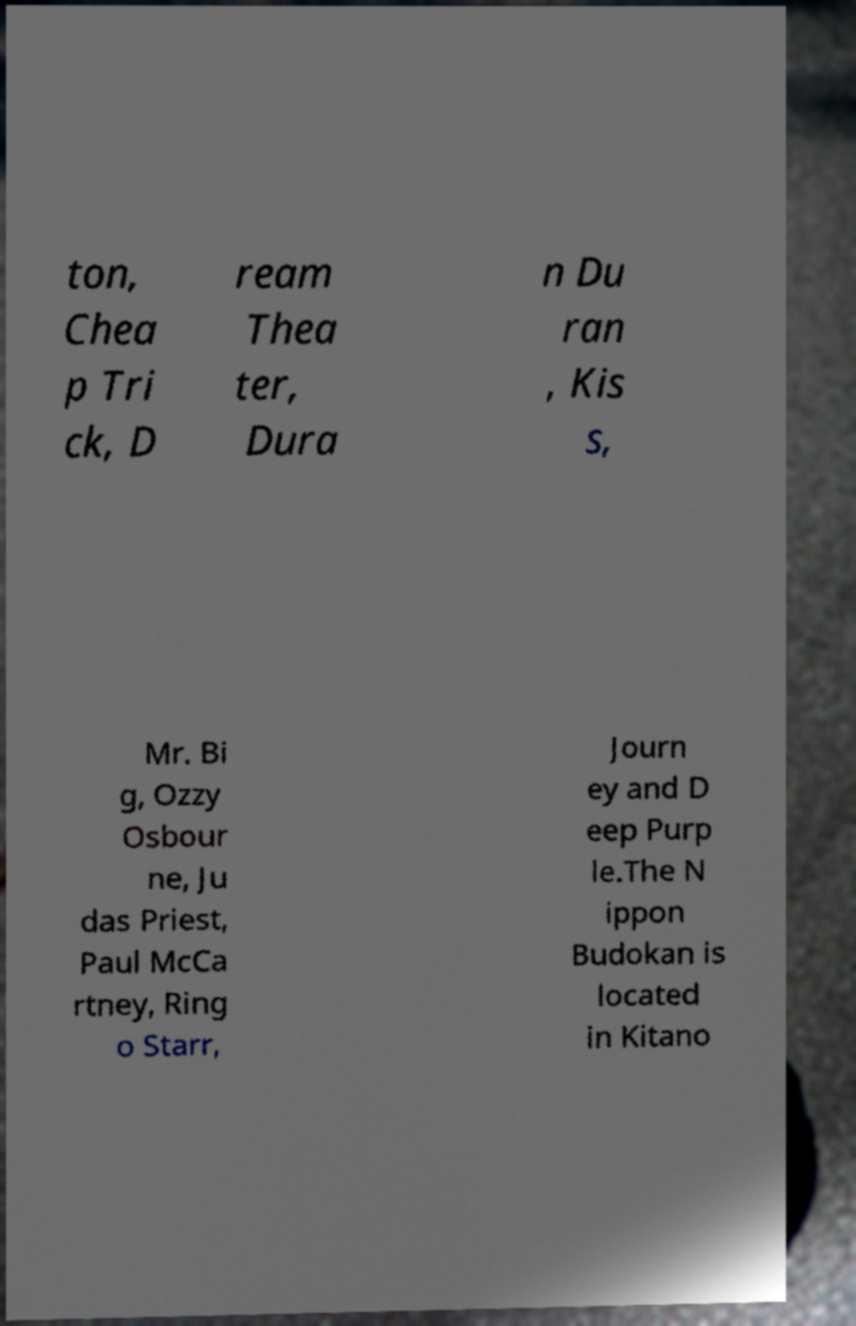Can you read and provide the text displayed in the image?This photo seems to have some interesting text. Can you extract and type it out for me? ton, Chea p Tri ck, D ream Thea ter, Dura n Du ran , Kis s, Mr. Bi g, Ozzy Osbour ne, Ju das Priest, Paul McCa rtney, Ring o Starr, Journ ey and D eep Purp le.The N ippon Budokan is located in Kitano 